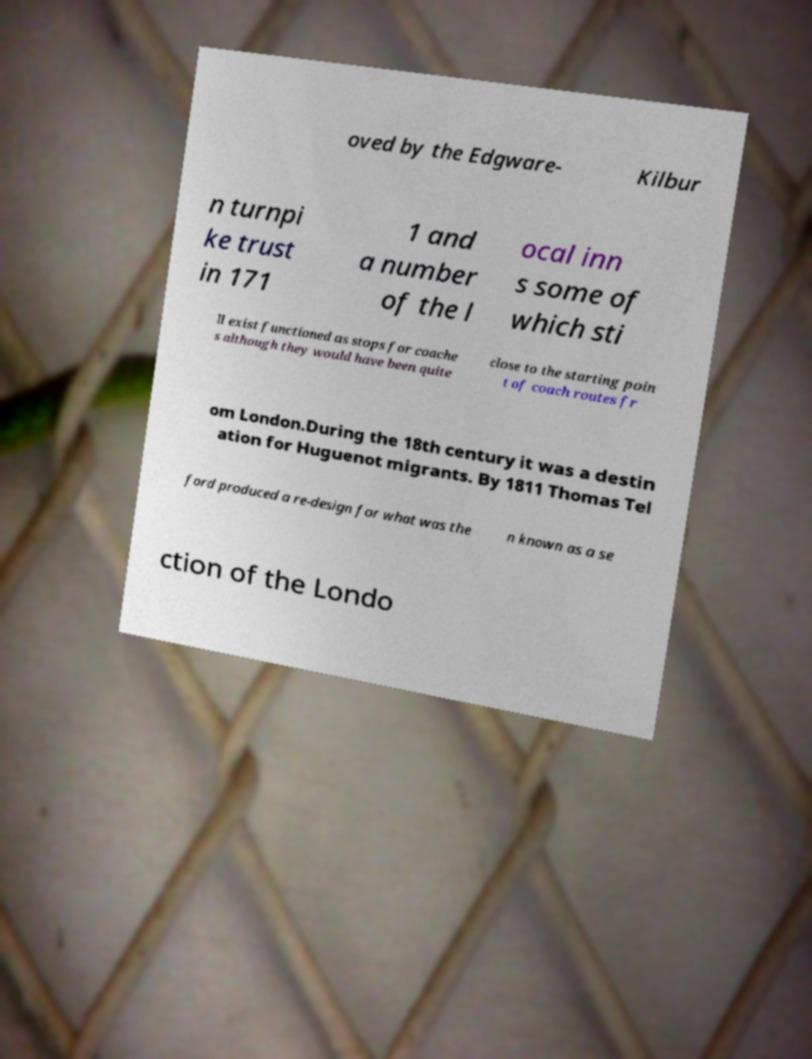Can you read and provide the text displayed in the image?This photo seems to have some interesting text. Can you extract and type it out for me? oved by the Edgware- Kilbur n turnpi ke trust in 171 1 and a number of the l ocal inn s some of which sti ll exist functioned as stops for coache s although they would have been quite close to the starting poin t of coach routes fr om London.During the 18th century it was a destin ation for Huguenot migrants. By 1811 Thomas Tel ford produced a re-design for what was the n known as a se ction of the Londo 